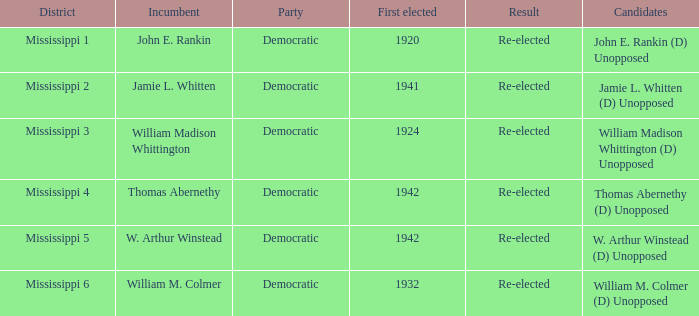Who is the current officeholder from 1941? Jamie L. Whitten. Parse the table in full. {'header': ['District', 'Incumbent', 'Party', 'First elected', 'Result', 'Candidates'], 'rows': [['Mississippi 1', 'John E. Rankin', 'Democratic', '1920', 'Re-elected', 'John E. Rankin (D) Unopposed'], ['Mississippi 2', 'Jamie L. Whitten', 'Democratic', '1941', 'Re-elected', 'Jamie L. Whitten (D) Unopposed'], ['Mississippi 3', 'William Madison Whittington', 'Democratic', '1924', 'Re-elected', 'William Madison Whittington (D) Unopposed'], ['Mississippi 4', 'Thomas Abernethy', 'Democratic', '1942', 'Re-elected', 'Thomas Abernethy (D) Unopposed'], ['Mississippi 5', 'W. Arthur Winstead', 'Democratic', '1942', 'Re-elected', 'W. Arthur Winstead (D) Unopposed'], ['Mississippi 6', 'William M. Colmer', 'Democratic', '1932', 'Re-elected', 'William M. Colmer (D) Unopposed']]} 